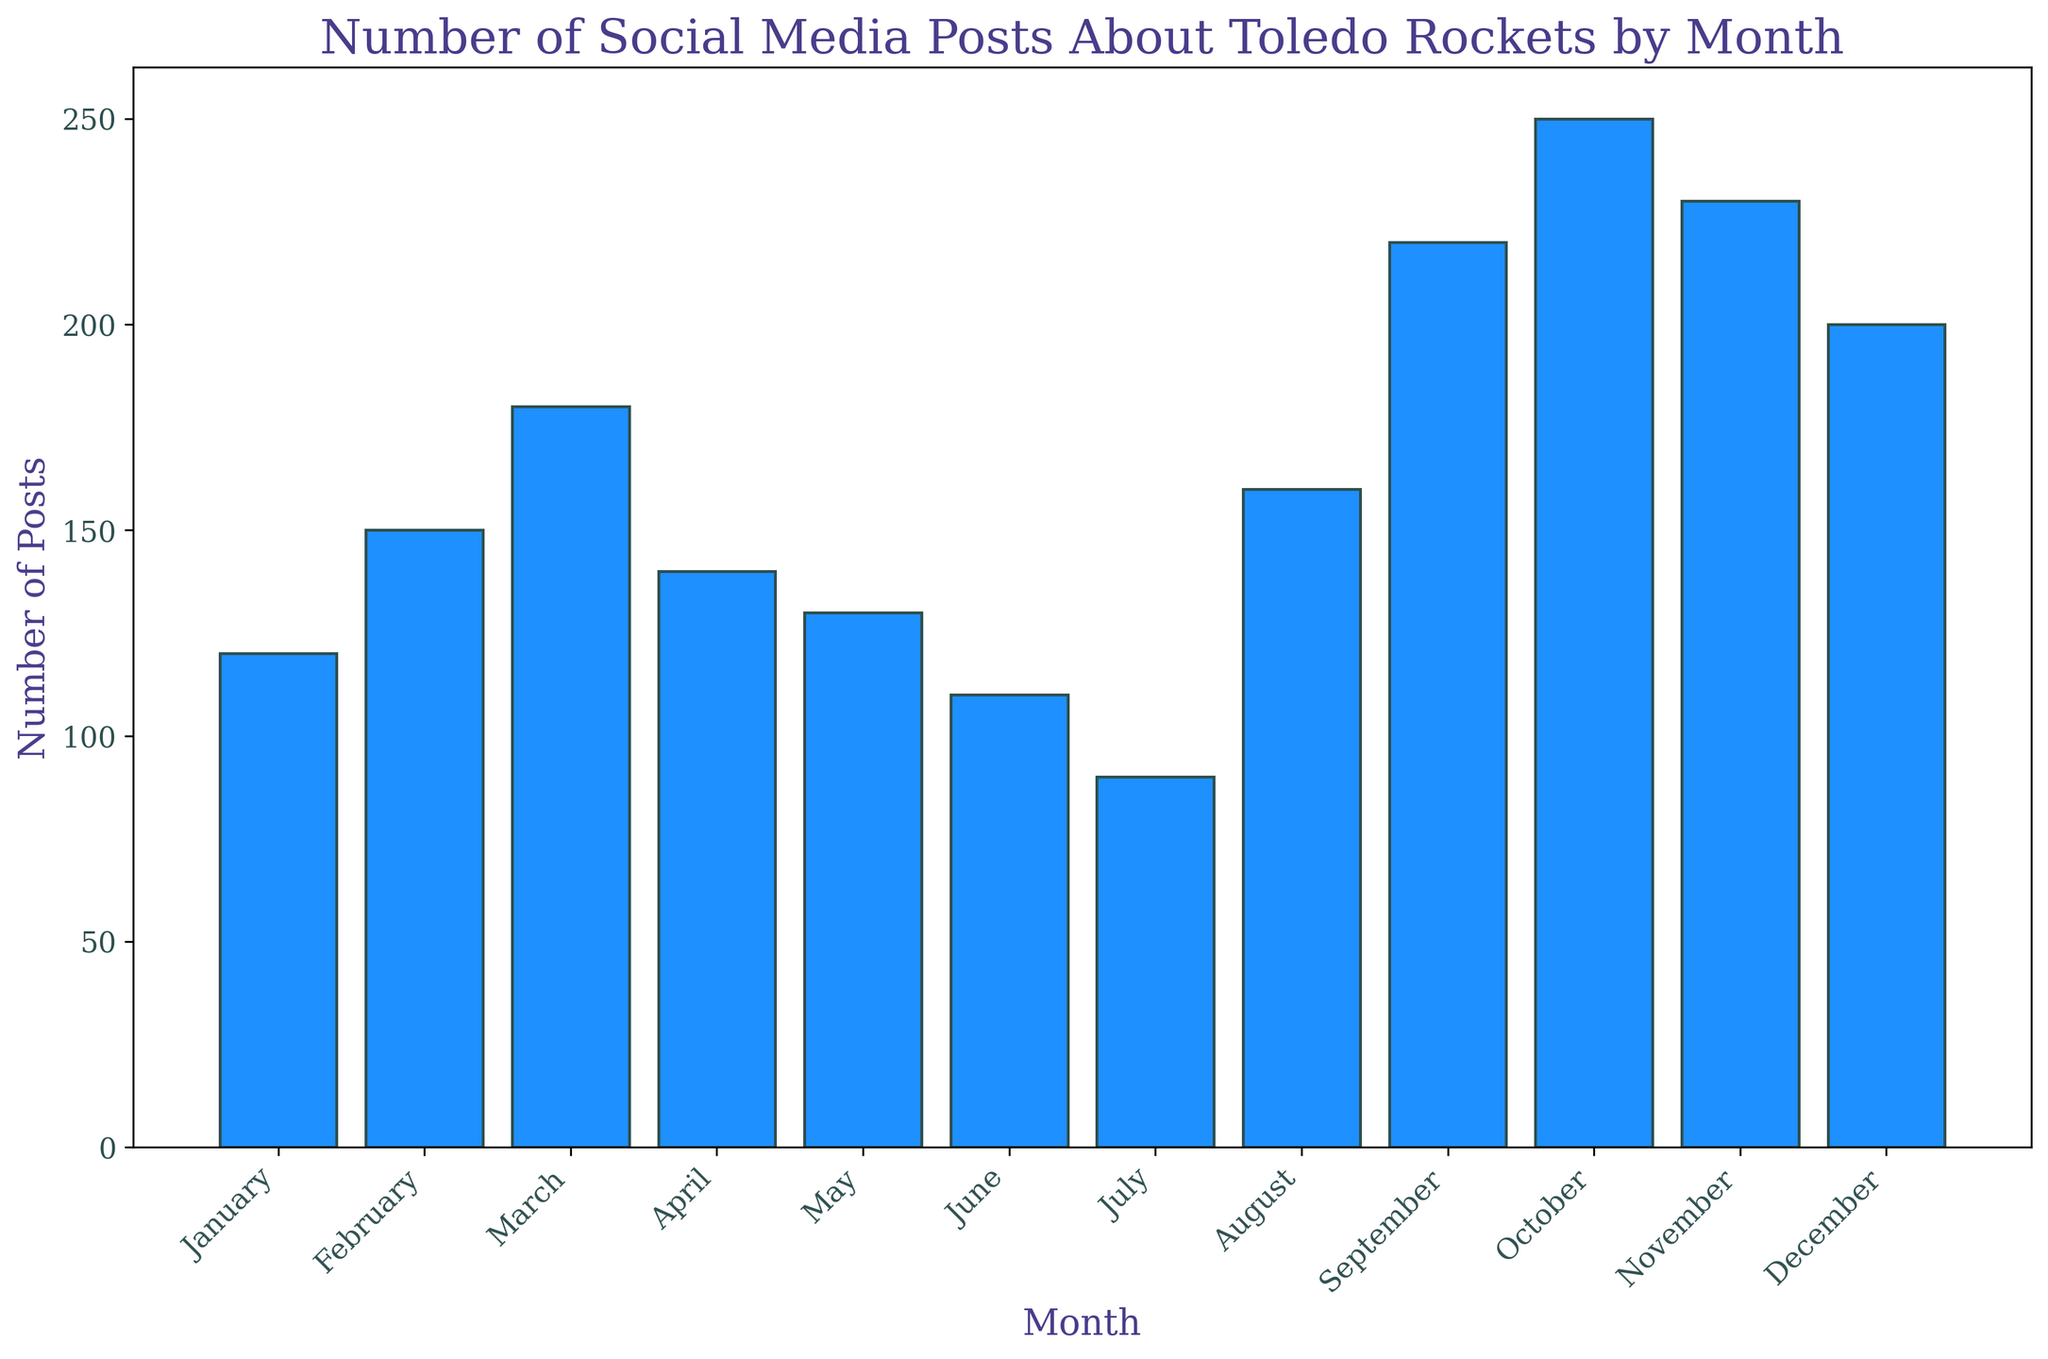Which month had the highest number of social media posts about Toledo Rockets? Identify the tallest bar in the histogram, which represents October with 250 posts.
Answer: October Which months have fewer than 100 social media posts? Identify bars with heights corresponding to less than 100 posts, which are July with 90 posts.
Answer: July What is the difference in the number of posts between September and December? Subtract the number of posts in December (200) from the number in September (220): 220 - 200 = 20.
Answer: 20 What is the average number of posts from January to June? Sum the posts from January (120), February (150), March (180), April (140), May (130), and June (110). Average is (120 + 150 + 180 + 140 + 130 + 110) / 6 = 830 / 6 ≈ 138.33.
Answer: 138.33 In which months did the number of posts increase by more than 30 compared to the previous month? Check the difference between consecutive months:
January to February: 150 - 120 = 30,
February to March: 180 - 150 = 30,
March to April: 180 - 140 = 40 (not valid),
April to May: 140 - 130 = 10,
May to June: 130 - 110 = 20,
June to July: 110 - 90 = 20,
July to August: 160 - 90 = 70,
August to September: 220 - 160 = 60,
September to October: 250 - 220 = 30,
October to November: 230 - 250 = -20,
November to December: 200 - 230 = -30.
Valid months: March, August, and September.
Answer: March, August, and September How many months have more than 200 posts? Count the bars with heights representing more than 200 posts: September, October, November, and December.
Answer: Four What is the total number of posts for the entire year? Sum the number of posts for all months. Total = 120 + 150 + 180 + 140 + 130 + 110 + 90 + 160 + 220 + 250 + 230 + 200 = 2180.
Answer: 2180 Which months had more posts: April or May? Compare the heights of the bars for April (140 posts) and May (130 posts).
Answer: April By how much did the number of posts decrease from November to December? Subtract December posts (200) from November posts (230): 230 - 200 = 30.
Answer: 30 What is the median number of posts for the year? Arrange the monthly posts in ascending order: 90, 110, 120, 130, 140, 150, 160, 180, 200, 220, 230, 250. The middle values are 150 and 160, so the median is (150 + 160) / 2 = 155.
Answer: 155 